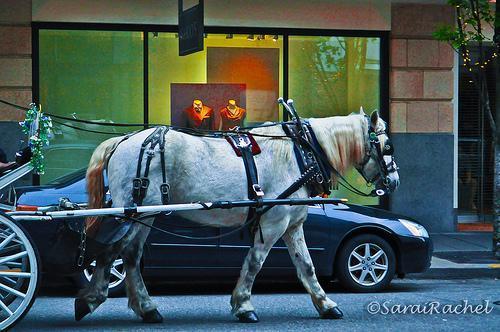How many car?
Give a very brief answer. 1. 